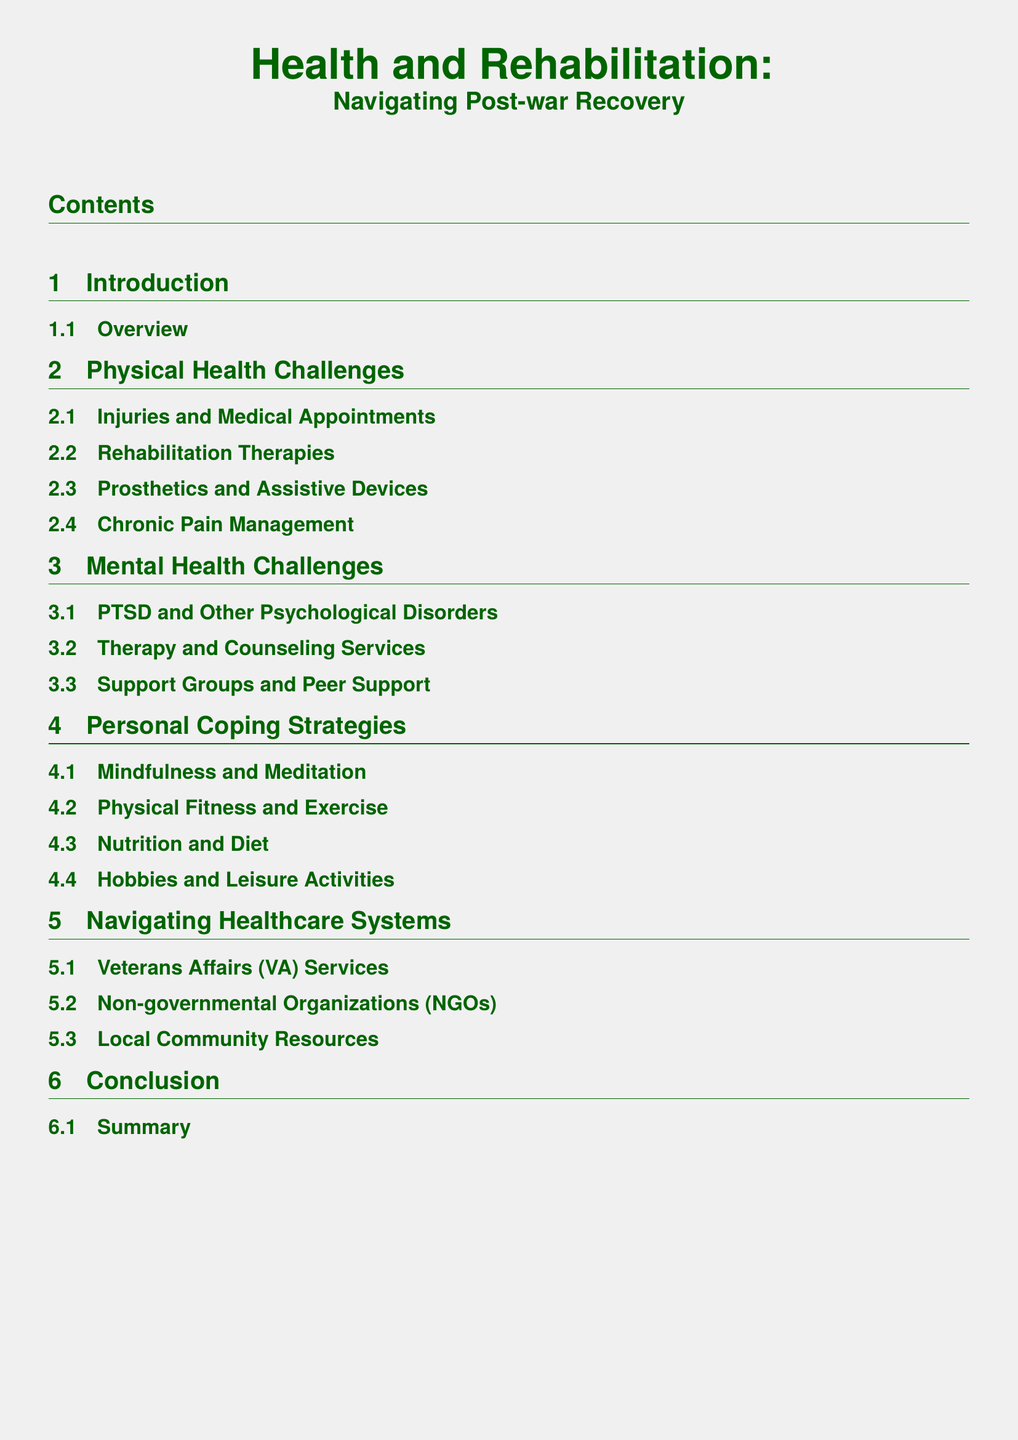what is the title of the document? The title is stated at the top of the document, indicating the focus on health and rehabilitation in post-war recovery.
Answer: Health and Rehabilitation: Navigating Post-war Recovery how many sections are there in the document? The document contains five main sections, as listed in the table of contents.
Answer: 5 what is the second subsection under Mental Health Challenges? The subsections under Mental Health Challenges are listed sequentially, with the second being therapy-focused.
Answer: Therapy and Counseling Services what recovery strategy is mentioned for mental health challenges? The document lists personal coping strategies, which include methods for dealing with mental health.
Answer: Support Groups and Peer Support which organization provides specific services mentioned in navigating healthcare systems? The document explicitly mentions organizations dedicated to veterans' health services, providing context for healthcare options.
Answer: Veterans Affairs (VA) Services what is the final section of the document? The conclusion summarizes the findings, forming the last section of the document presented in the table of contents.
Answer: Conclusion how many subsections are listed under Physical Health Challenges? The section on physical health challenges includes a specific number of detailed subsections.
Answer: 4 what personal strategy is included for managing physical health? There’s a focus on maintaining physical fitness as part of personal coping strategies aimed at overall health recovery.
Answer: Physical Fitness and Exercise what is the primary focus of the Introduction section? The introduction provides an overview, establishing the context for the following sections.
Answer: Overview 